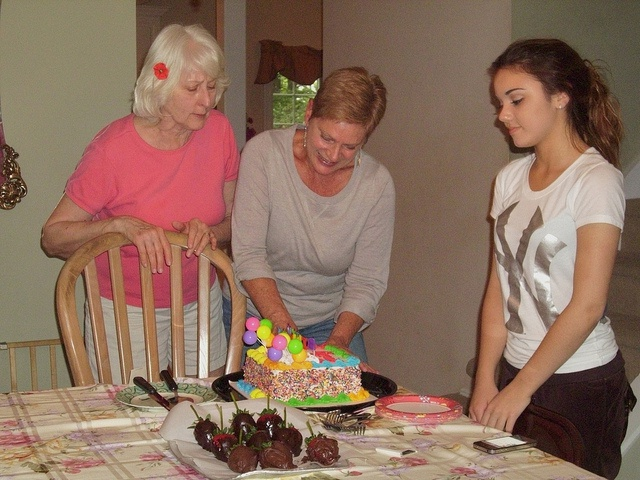Describe the objects in this image and their specific colors. I can see people in gray, black, tan, and darkgray tones, dining table in gray and tan tones, people in gray, brown, salmon, tan, and darkgray tones, people in gray, darkgray, and brown tones, and chair in gray, brown, darkgray, and tan tones in this image. 